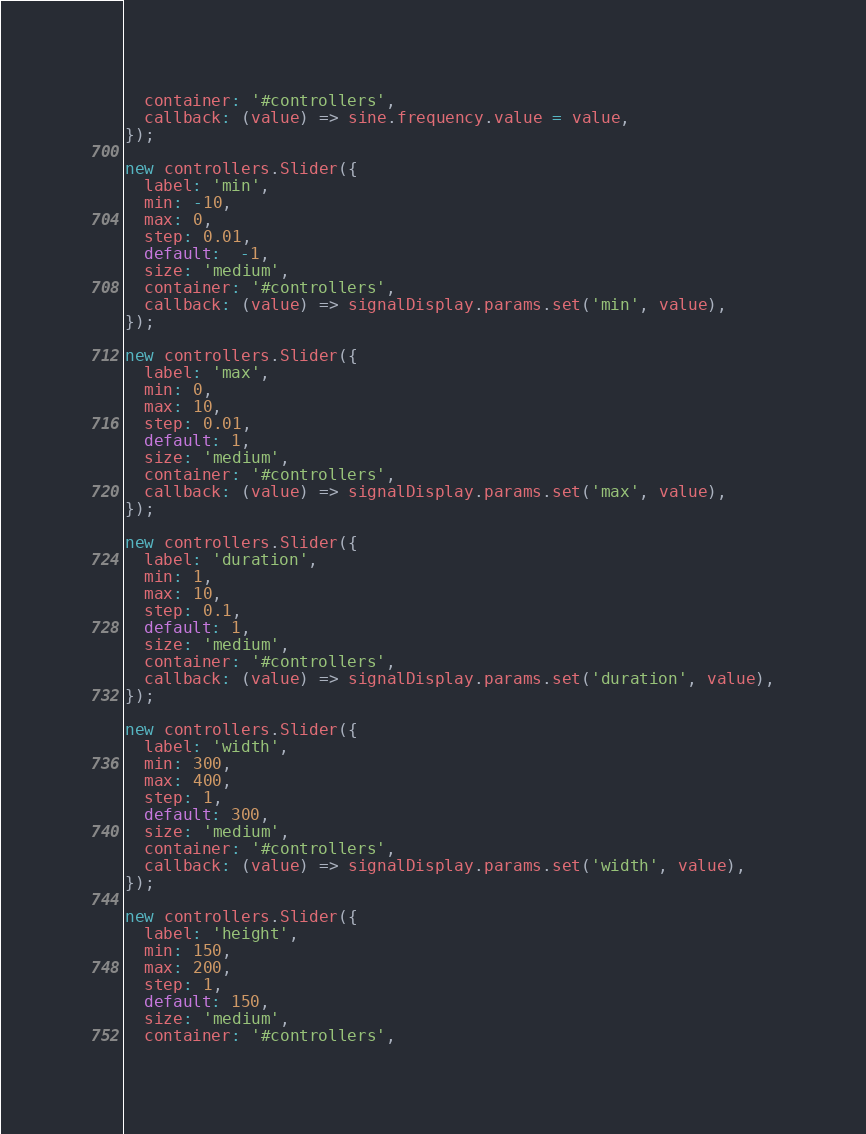<code> <loc_0><loc_0><loc_500><loc_500><_JavaScript_>  container: '#controllers',
  callback: (value) => sine.frequency.value = value,
});

new controllers.Slider({
  label: 'min',
  min: -10,
  max: 0,
  step: 0.01,
  default:  -1,
  size: 'medium',
  container: '#controllers',
  callback: (value) => signalDisplay.params.set('min', value),
});

new controllers.Slider({
  label: 'max',
  min: 0,
  max: 10,
  step: 0.01,
  default: 1,
  size: 'medium',
  container: '#controllers',
  callback: (value) => signalDisplay.params.set('max', value),
});

new controllers.Slider({
  label: 'duration',
  min: 1,
  max: 10,
  step: 0.1,
  default: 1,
  size: 'medium',
  container: '#controllers',
  callback: (value) => signalDisplay.params.set('duration', value),
});

new controllers.Slider({
  label: 'width',
  min: 300,
  max: 400,
  step: 1,
  default: 300,
  size: 'medium',
  container: '#controllers',
  callback: (value) => signalDisplay.params.set('width', value),
});

new controllers.Slider({
  label: 'height',
  min: 150,
  max: 200,
  step: 1,
  default: 150,
  size: 'medium',
  container: '#controllers',</code> 